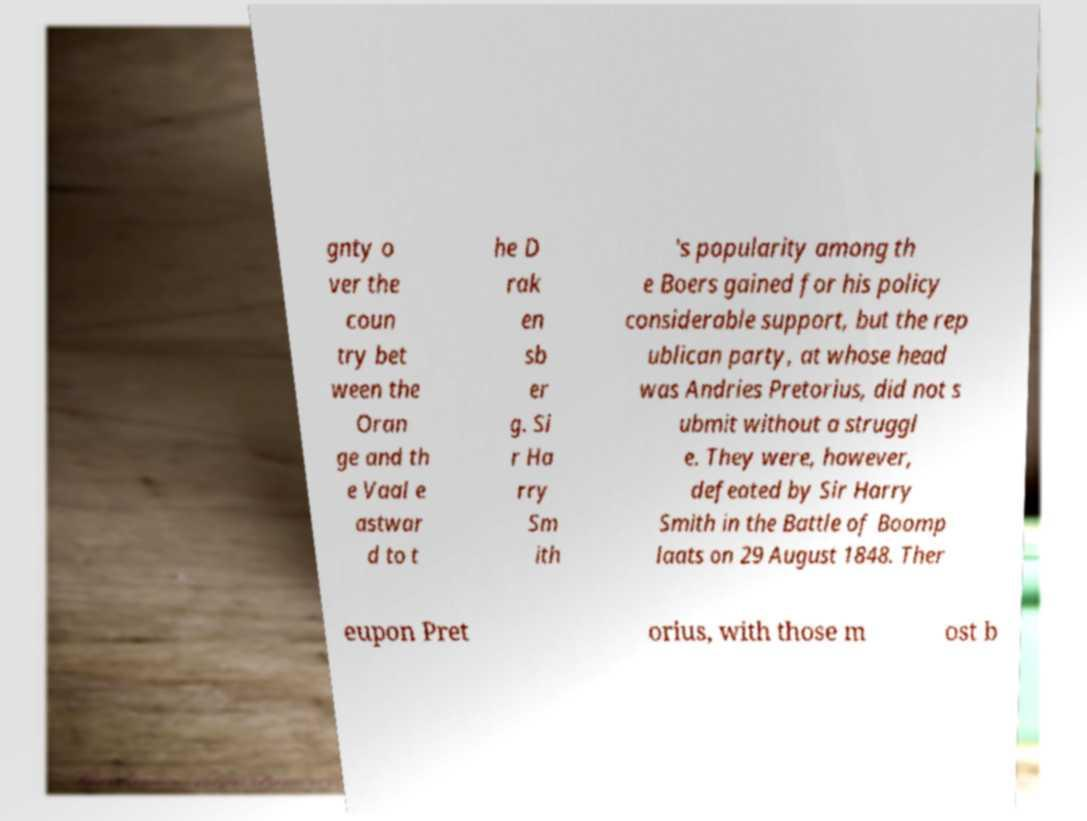Please read and relay the text visible in this image. What does it say? gnty o ver the coun try bet ween the Oran ge and th e Vaal e astwar d to t he D rak en sb er g. Si r Ha rry Sm ith 's popularity among th e Boers gained for his policy considerable support, but the rep ublican party, at whose head was Andries Pretorius, did not s ubmit without a struggl e. They were, however, defeated by Sir Harry Smith in the Battle of Boomp laats on 29 August 1848. Ther eupon Pret orius, with those m ost b 